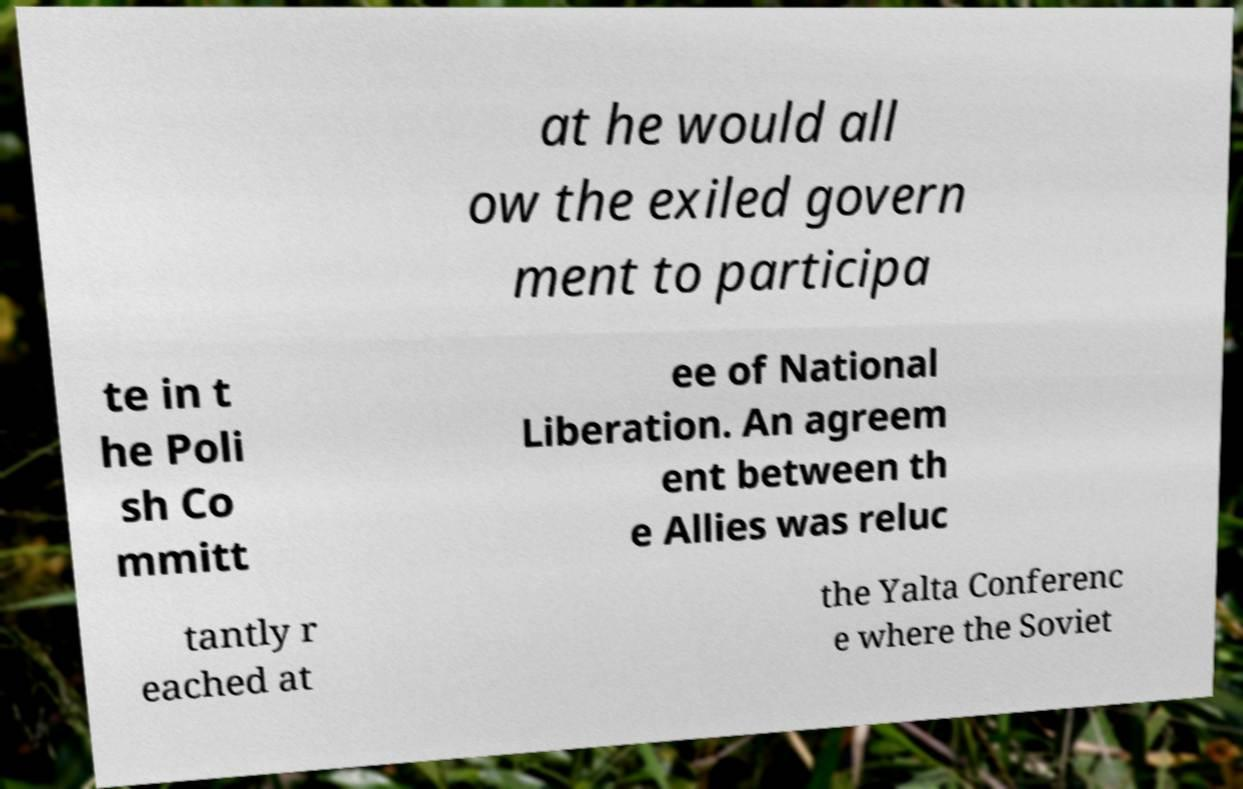Can you read and provide the text displayed in the image?This photo seems to have some interesting text. Can you extract and type it out for me? at he would all ow the exiled govern ment to participa te in t he Poli sh Co mmitt ee of National Liberation. An agreem ent between th e Allies was reluc tantly r eached at the Yalta Conferenc e where the Soviet 